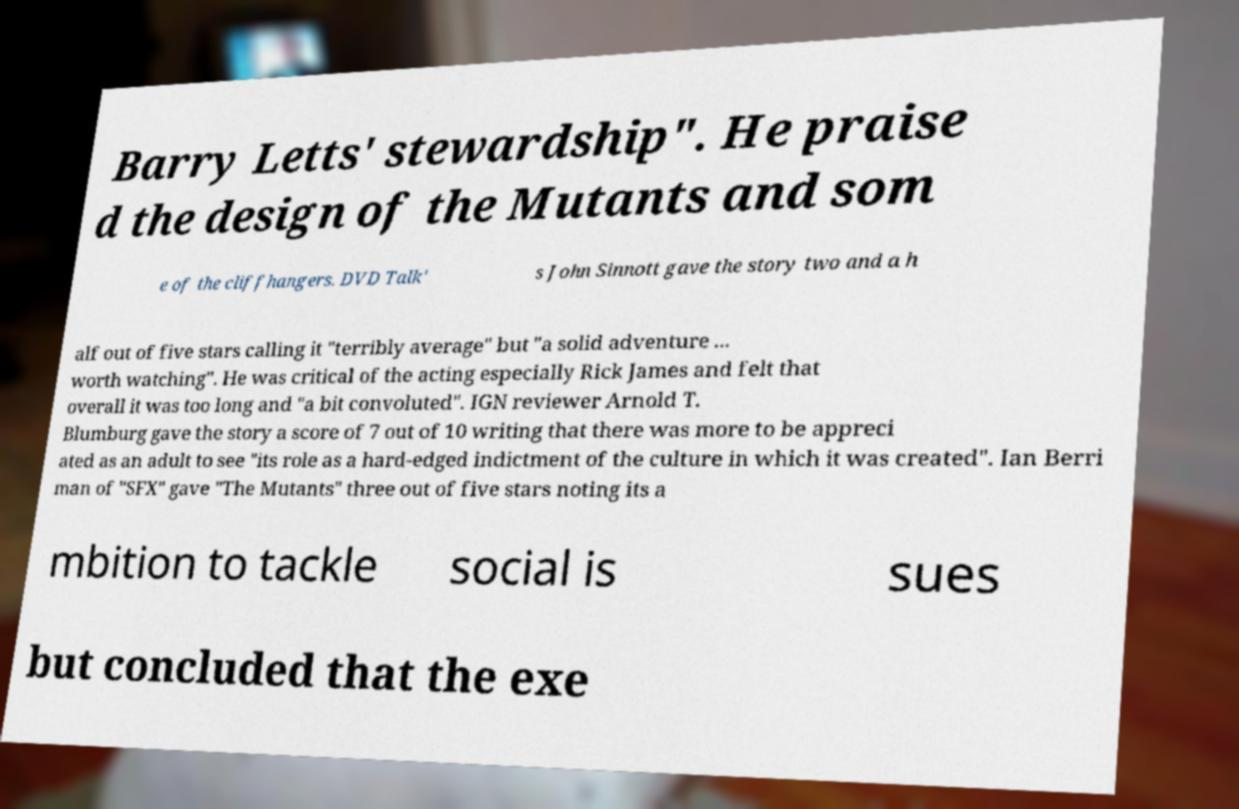Can you read and provide the text displayed in the image?This photo seems to have some interesting text. Can you extract and type it out for me? Barry Letts' stewardship". He praise d the design of the Mutants and som e of the cliffhangers. DVD Talk' s John Sinnott gave the story two and a h alf out of five stars calling it "terribly average" but "a solid adventure ... worth watching". He was critical of the acting especially Rick James and felt that overall it was too long and "a bit convoluted". IGN reviewer Arnold T. Blumburg gave the story a score of 7 out of 10 writing that there was more to be appreci ated as an adult to see "its role as a hard-edged indictment of the culture in which it was created". Ian Berri man of "SFX" gave "The Mutants" three out of five stars noting its a mbition to tackle social is sues but concluded that the exe 